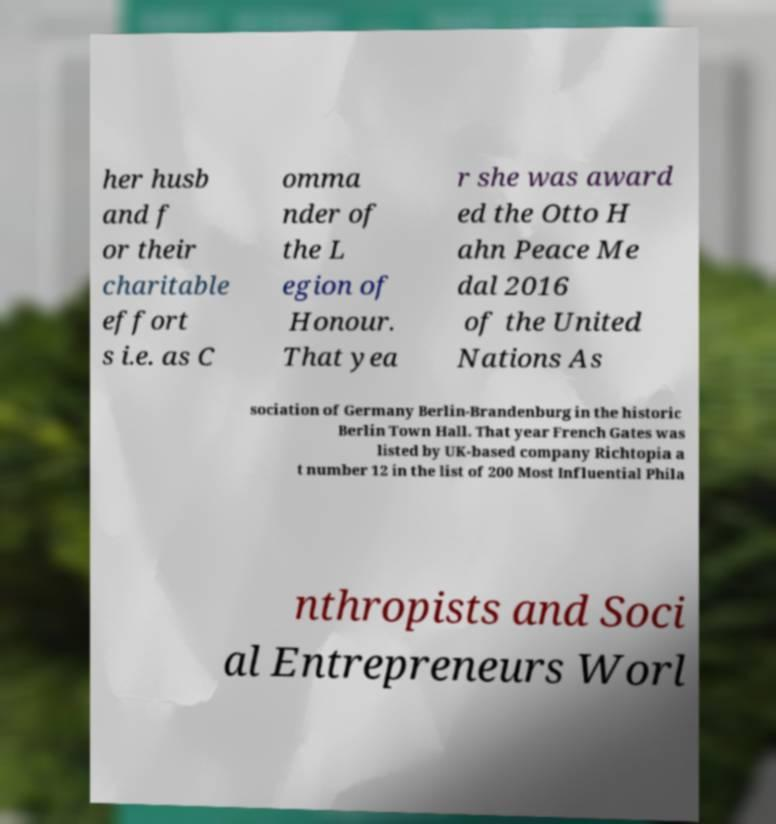Can you accurately transcribe the text from the provided image for me? her husb and f or their charitable effort s i.e. as C omma nder of the L egion of Honour. That yea r she was award ed the Otto H ahn Peace Me dal 2016 of the United Nations As sociation of Germany Berlin-Brandenburg in the historic Berlin Town Hall. That year French Gates was listed by UK-based company Richtopia a t number 12 in the list of 200 Most Influential Phila nthropists and Soci al Entrepreneurs Worl 